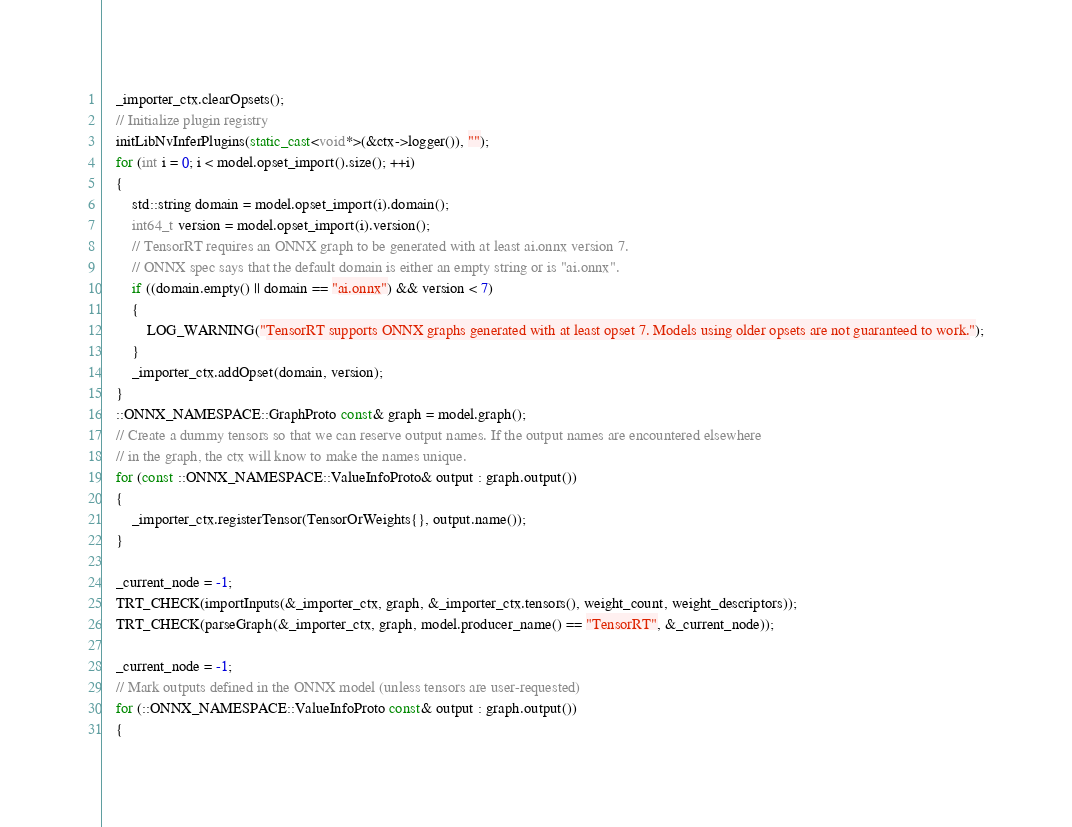Convert code to text. <code><loc_0><loc_0><loc_500><loc_500><_C++_>    _importer_ctx.clearOpsets();
    // Initialize plugin registry
    initLibNvInferPlugins(static_cast<void*>(&ctx->logger()), "");
    for (int i = 0; i < model.opset_import().size(); ++i)
    {
        std::string domain = model.opset_import(i).domain();
        int64_t version = model.opset_import(i).version();
        // TensorRT requires an ONNX graph to be generated with at least ai.onnx version 7.
        // ONNX spec says that the default domain is either an empty string or is "ai.onnx".
        if ((domain.empty() || domain == "ai.onnx") && version < 7)
        {
            LOG_WARNING("TensorRT supports ONNX graphs generated with at least opset 7. Models using older opsets are not guaranteed to work.");
        }
        _importer_ctx.addOpset(domain, version);
    }
    ::ONNX_NAMESPACE::GraphProto const& graph = model.graph();
    // Create a dummy tensors so that we can reserve output names. If the output names are encountered elsewhere
    // in the graph, the ctx will know to make the names unique.
    for (const ::ONNX_NAMESPACE::ValueInfoProto& output : graph.output())
    {
        _importer_ctx.registerTensor(TensorOrWeights{}, output.name());
    }

    _current_node = -1;
    TRT_CHECK(importInputs(&_importer_ctx, graph, &_importer_ctx.tensors(), weight_count, weight_descriptors));
    TRT_CHECK(parseGraph(&_importer_ctx, graph, model.producer_name() == "TensorRT", &_current_node));

    _current_node = -1;
    // Mark outputs defined in the ONNX model (unless tensors are user-requested)
    for (::ONNX_NAMESPACE::ValueInfoProto const& output : graph.output())
    {</code> 